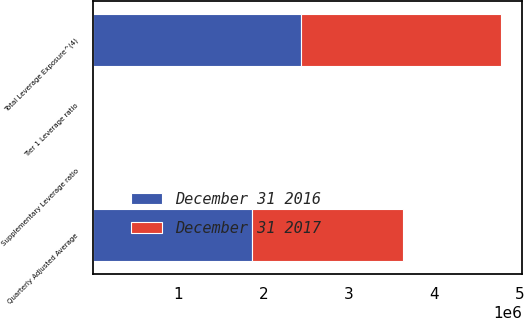Convert chart. <chart><loc_0><loc_0><loc_500><loc_500><stacked_bar_chart><ecel><fcel>Quarterly Adjusted Average<fcel>Total Leverage Exposure^(4)<fcel>Tier 1 Leverage ratio<fcel>Supplementary Leverage ratio<nl><fcel>December 31 2016<fcel>1.86921e+06<fcel>2.43337e+06<fcel>8.82<fcel>6.77<nl><fcel>December 31 2017<fcel>1.76842e+06<fcel>2.35188e+06<fcel>10.09<fcel>7.58<nl></chart> 